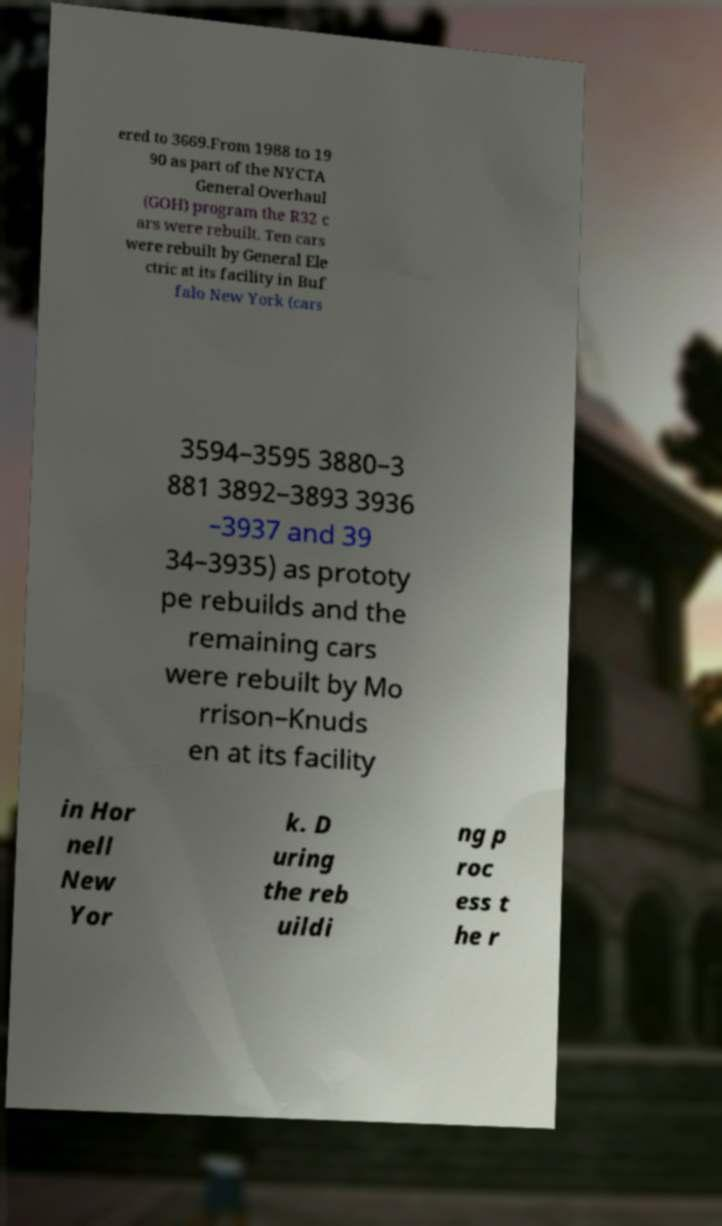There's text embedded in this image that I need extracted. Can you transcribe it verbatim? ered to 3669.From 1988 to 19 90 as part of the NYCTA General Overhaul (GOH) program the R32 c ars were rebuilt. Ten cars were rebuilt by General Ele ctric at its facility in Buf falo New York (cars 3594–3595 3880–3 881 3892–3893 3936 –3937 and 39 34–3935) as prototy pe rebuilds and the remaining cars were rebuilt by Mo rrison–Knuds en at its facility in Hor nell New Yor k. D uring the reb uildi ng p roc ess t he r 